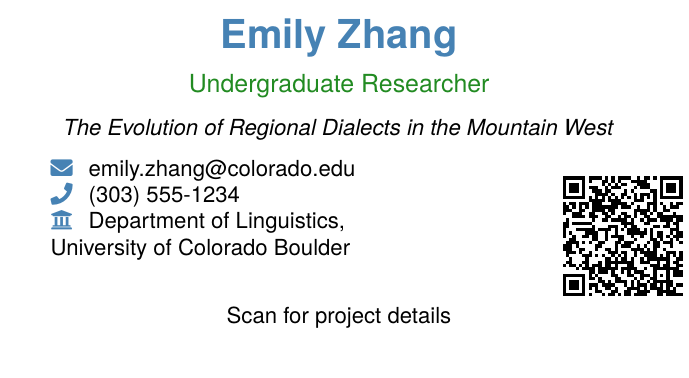What is the name of the researcher? The name of the researcher is prominently displayed at the top of the business card.
Answer: Emily Zhang What is the research project title? The title of the research project is provided in italics below the researcher's name.
Answer: The Evolution of Regional Dialects in the Mountain West What is the researcher's email address? The email address is listed under the key contact information section of the card.
Answer: emily.zhang@colorado.edu What is the researcher's phone number? The phone number is included in the contact information section.
Answer: (303) 555-1234 Which university is associated with the researcher? The university name is mentioned in the contact details section.
Answer: University of Colorado Boulder What is the color theme of the business card? The business card features specific colors in its design, which can be inferred from the text descriptions.
Answer: Mountain blue and mountain green What can you do with the QR code on the card? The QR code links to a detailed description or material related to the research project.
Answer: Scan for project details What department is the researcher part of? The department is mentioned alongside the university information.
Answer: Department of Linguistics What type of document is this? The structure and content indicate the nature of the document.
Answer: Business card 